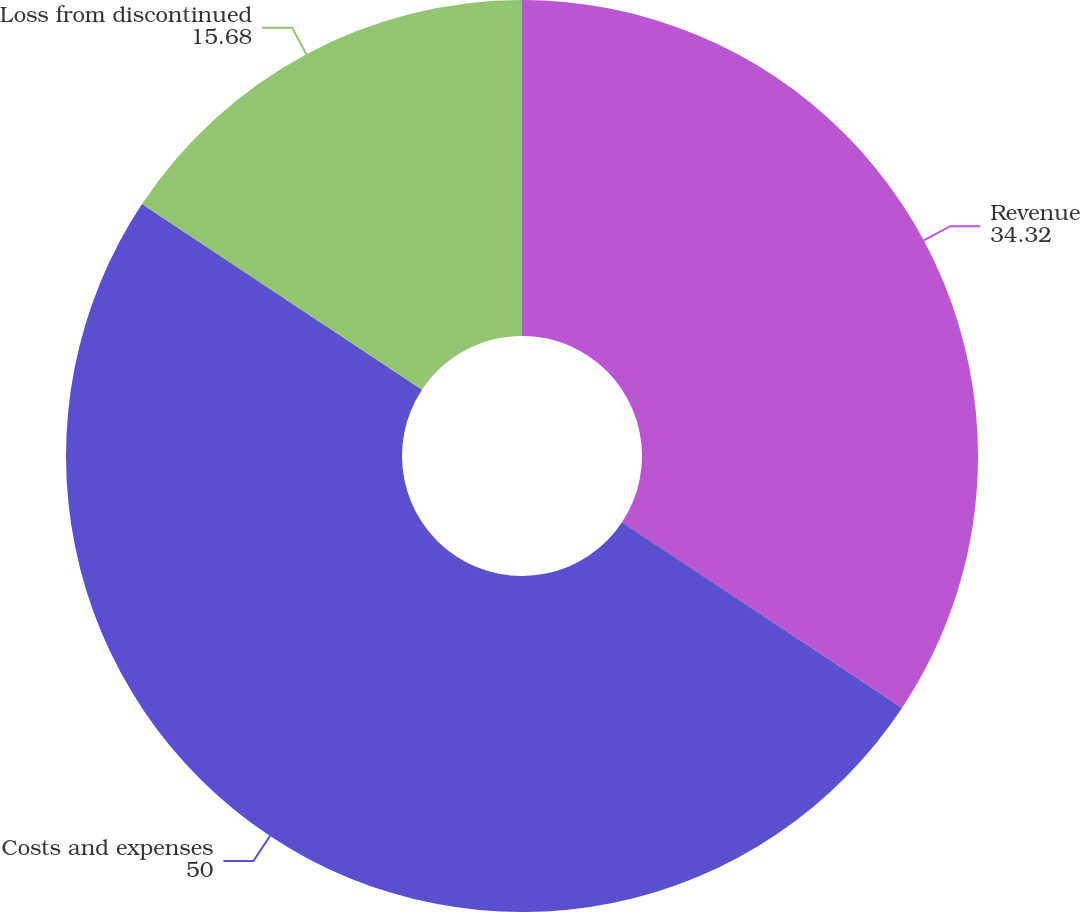Convert chart to OTSL. <chart><loc_0><loc_0><loc_500><loc_500><pie_chart><fcel>Revenue<fcel>Costs and expenses<fcel>Loss from discontinued<nl><fcel>34.32%<fcel>50.0%<fcel>15.68%<nl></chart> 